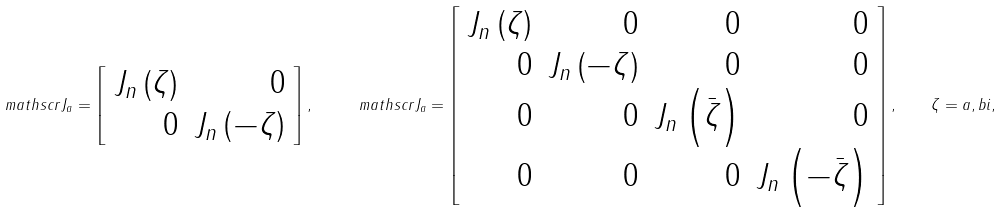Convert formula to latex. <formula><loc_0><loc_0><loc_500><loc_500>\ m a t h s c r { J } _ { a } = \left [ \begin{array} { r r } J _ { n } \left ( \zeta \right ) & 0 \\ 0 & J _ { n } \left ( - \zeta \right ) \end{array} \right ] , \quad \ m a t h s c r { J } _ { a } = \left [ \begin{array} { r r r r } J _ { n } \left ( \zeta \right ) & 0 & 0 & 0 \\ 0 & J _ { n } \left ( - \zeta \right ) & 0 & 0 \\ 0 & 0 & J _ { n } \left ( \bar { \zeta } \right ) & 0 \\ 0 & 0 & 0 & J _ { n } \left ( - \bar { \zeta } \right ) \end{array} \right ] , \quad \zeta = a , b i ,</formula> 